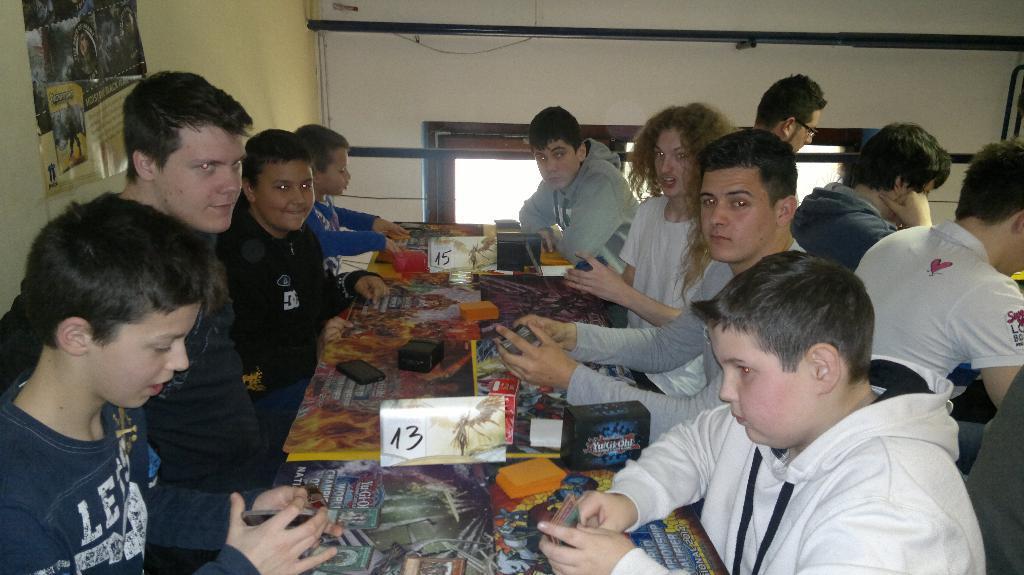How would you summarize this image in a sentence or two? In this image there are four persons sitting at left side of this image and four persons sitting in middle of this image and three persons at right side of this image and there is a wall in the background and there is a sticker attached on the wall at top left side of this image. there is a table in middle of this image and there are some objects kept on this table , there is a table at left side of this image. 